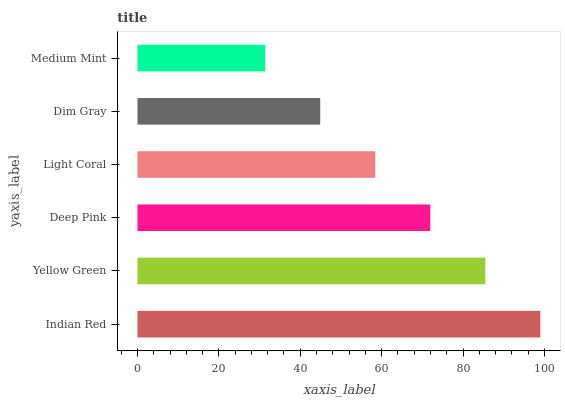Is Medium Mint the minimum?
Answer yes or no. Yes. Is Indian Red the maximum?
Answer yes or no. Yes. Is Yellow Green the minimum?
Answer yes or no. No. Is Yellow Green the maximum?
Answer yes or no. No. Is Indian Red greater than Yellow Green?
Answer yes or no. Yes. Is Yellow Green less than Indian Red?
Answer yes or no. Yes. Is Yellow Green greater than Indian Red?
Answer yes or no. No. Is Indian Red less than Yellow Green?
Answer yes or no. No. Is Deep Pink the high median?
Answer yes or no. Yes. Is Light Coral the low median?
Answer yes or no. Yes. Is Light Coral the high median?
Answer yes or no. No. Is Deep Pink the low median?
Answer yes or no. No. 